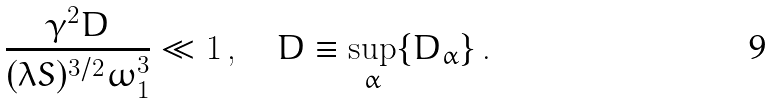<formula> <loc_0><loc_0><loc_500><loc_500>\frac { \gamma ^ { 2 } D } { ( \lambda S ) ^ { 3 / 2 } \omega _ { 1 } ^ { 3 } } \ll 1 \, , \quad D \equiv \sup _ { \alpha } \{ D _ { \alpha } \} \, .</formula> 